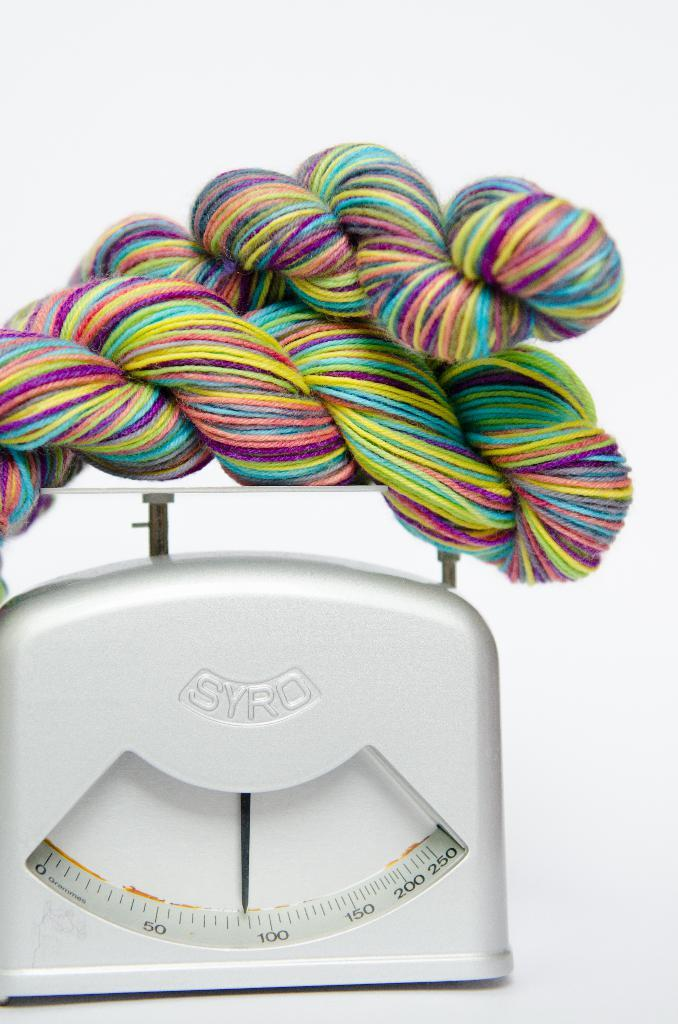What type of material is present in the image? There is colorful knitting wool in the image. How is the knitting wool being measured or organized? The knitting wool is kept on a white weighing machine. How many toes are visible on the foot in the image? There is no foot or toes present in the image; it only features colorful knitting wool and a white weighing machine. 